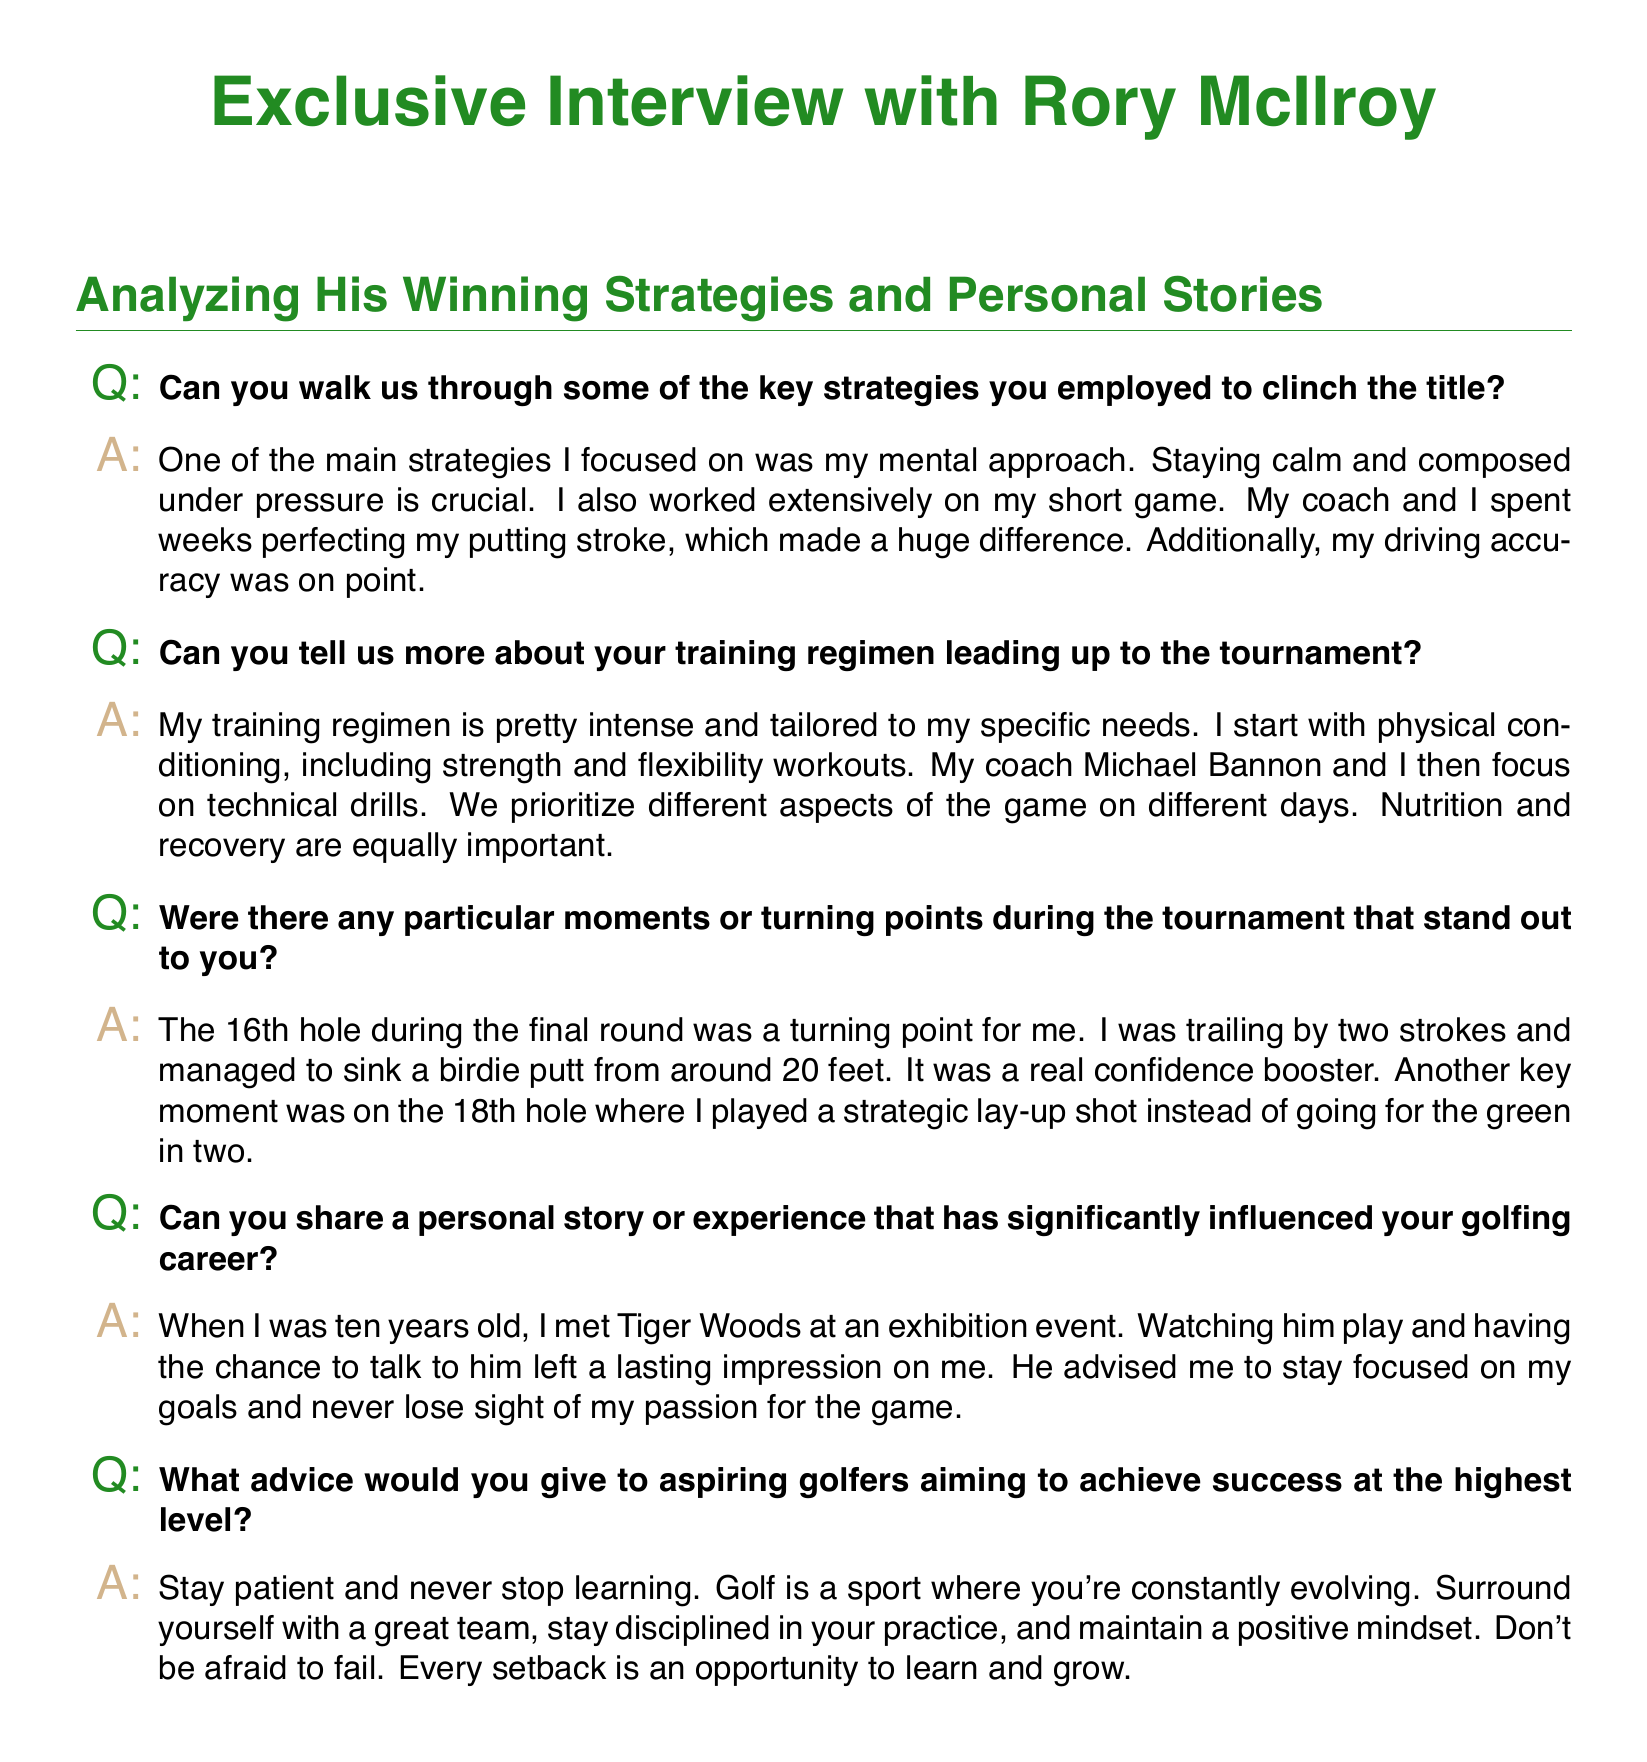What is the golfer's name? The document mentions the golfer's name at the beginning of the interview.
Answer: Rory McIlroy What was a key strategy mentioned for winning? The document details strategies used by Rory McIlroy, including his approach to pressure.
Answer: Mental approach Who is Rory McIlroy's coach? The interview references the name of Rory's coach when discussing training.
Answer: Michael Bannon What was a turning point during the tournament? The document highlights a specific hole that was crucial for McIlroy's performance.
Answer: 16th hole How old was Rory when he met Tiger Woods? The document provides information about an influential experience from Rory's childhood.
Answer: Ten years old What type of shot did McIlroy play on the 18th hole? The interview discusses Rory's strategy for the final hole, specifically the shot type.
Answer: Lay-up shot What advice does McIlroy give to aspiring golfers? The document contains a specific piece of advice intended for young athletes.
Answer: Stay patient What outcome did Rory achieve on the 16th hole? The interview mentions a specific result from a key moment during the tournament.
Answer: Birdie putt 